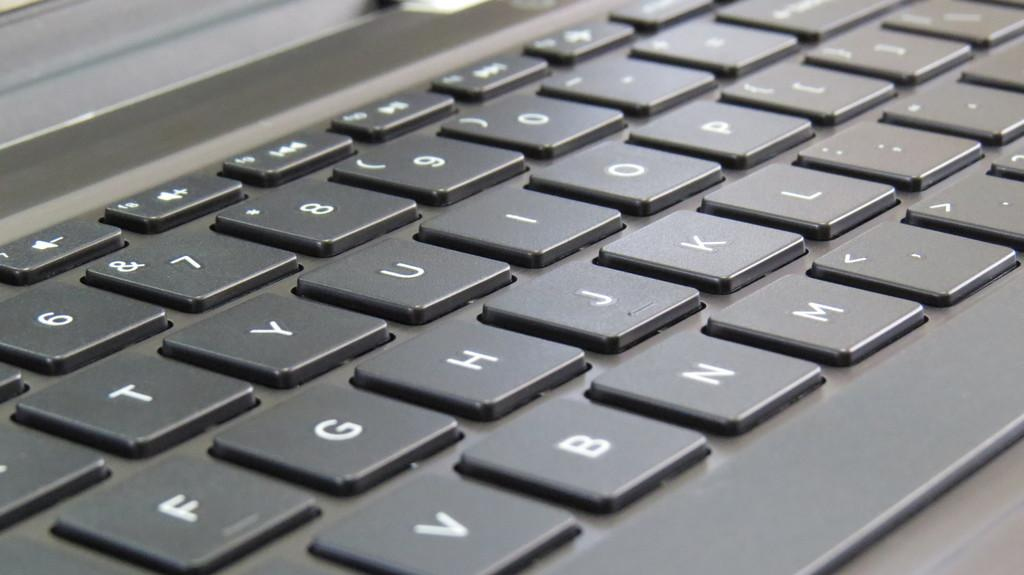<image>
Describe the image concisely. The black keyboard here is a standard QWERTY keyboard 